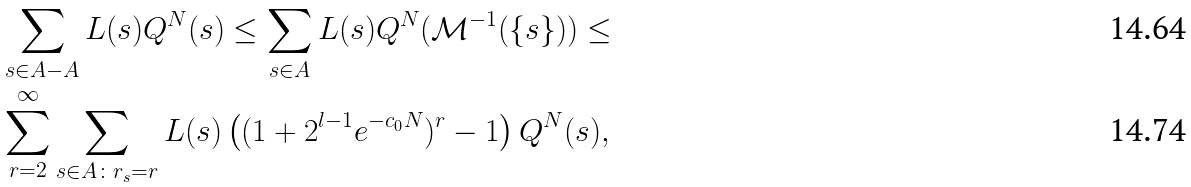Convert formula to latex. <formula><loc_0><loc_0><loc_500><loc_500>& \sum _ { s \in A - A } L ( s ) Q ^ { N } ( s ) \leq \sum _ { s \in A } L ( s ) Q ^ { N } ( \mathcal { M } ^ { - 1 } ( \{ s \} ) ) \leq \\ & \sum _ { r = 2 } ^ { \infty } \sum _ { s \in A \colon r _ { s } = r } L ( s ) \left ( ( 1 + 2 ^ { l - 1 } e ^ { - c _ { 0 } N } ) ^ { r } - 1 \right ) Q ^ { N } ( s ) ,</formula> 